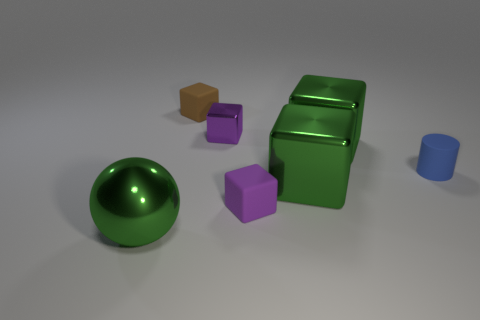Add 3 small yellow balls. How many objects exist? 10 Subtract all brown cubes. How many cubes are left? 4 Subtract all large metal cubes. How many cubes are left? 3 Subtract 1 blocks. How many blocks are left? 4 Subtract all cylinders. How many objects are left? 6 Subtract all cyan cubes. How many purple spheres are left? 0 Subtract all small red objects. Subtract all tiny brown matte things. How many objects are left? 6 Add 4 blocks. How many blocks are left? 9 Add 1 tiny matte cubes. How many tiny matte cubes exist? 3 Subtract 0 blue cubes. How many objects are left? 7 